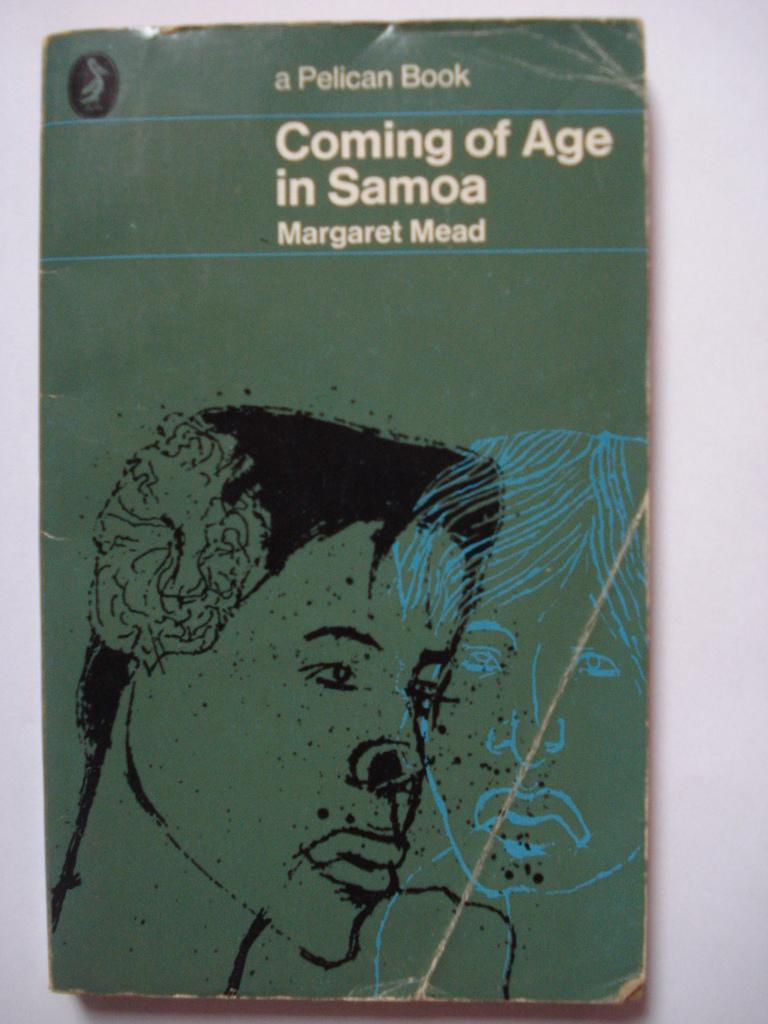What is the main object in the image? There is a book in the image. What type of content does the book contain? The book contains text. Are there any visual elements in the book? Yes, the book has images of two persons. What type of apparel is the brother wearing in the image? There is no brother or apparel present in the image; it only features a book with text and images of two persons. 